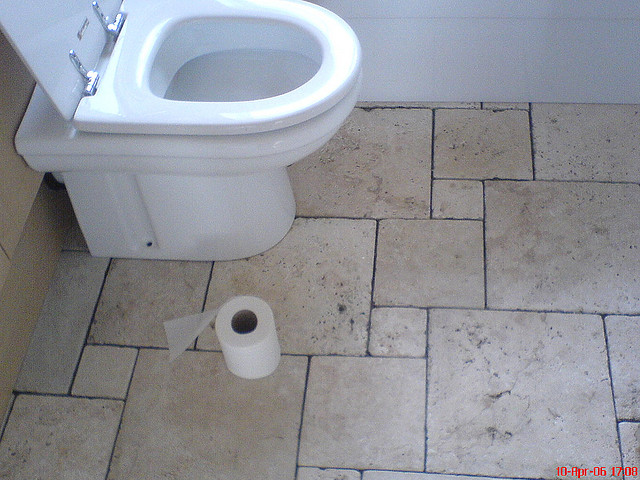Identify the text contained in this image. 08 17 06 Apr 10 